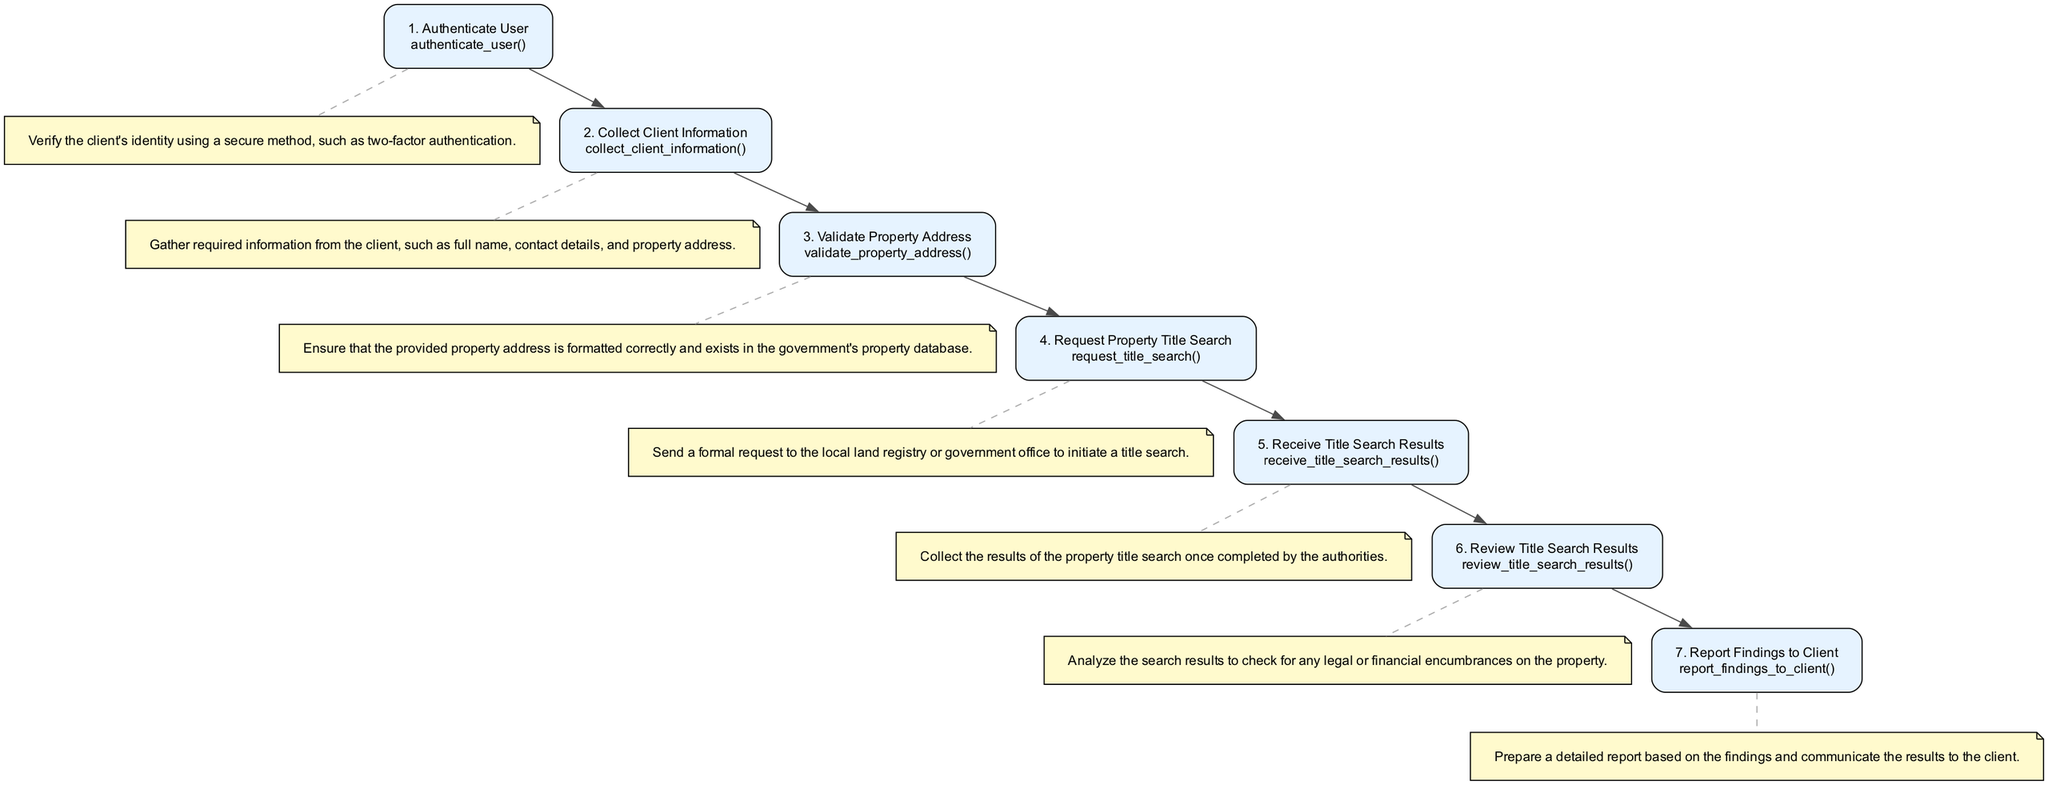What is the first action in the property title search process? The diagram shows the first action as "Authenticate User," which is listed in Step 1.
Answer: Authenticate User How many steps are there in total for requesting a property title search? By counting the nodes labeled with steps in the diagram, there are a total of seven actions listed.
Answer: 7 What is the last step of the process? The diagram indicates that the last step, which is Step 7, is "Report Findings to Client."
Answer: Report Findings to Client What function is associated with validating the property address? In Step 3, the diagram specifies the action as "Validate Property Address" and the corresponding function is "validate_property_address()."
Answer: validate_property_address() Which step involves reviewing the results of the title search? According to the flowchart, Step 6 specifically mentions "Review Title Search Results" as the action where the results are analyzed.
Answer: Review Title Search Results What is the relationship between Step 4 and Step 5? Step 4 involves "Request Property Title Search" and leads directly to Step 5, which is "Receive Title Search Results," indicating that the results are a consequence of the request made in Step 4.
Answer: Direct relationship Which action follows the collection of client information? The diagram illustrates that after collecting client information in Step 2, it is necessary to "Validate Property Address" in Step 3.
Answer: Validate Property Address What is a unique characteristic of the flowchart as it relates to function representation? Each step in the flowchart includes a function name associated with the corresponding action, providing clear segmentation of responsibilities for each process.
Answer: Function representation 